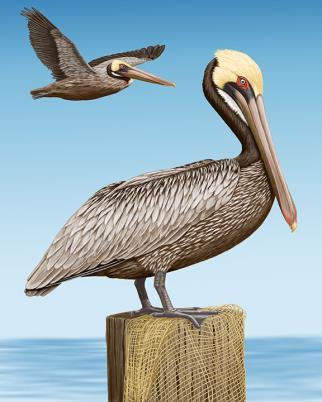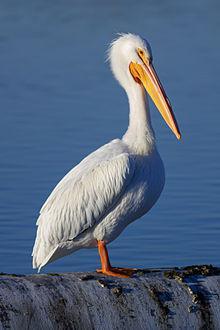The first image is the image on the left, the second image is the image on the right. Analyze the images presented: Is the assertion "One long-beaked bird is floating on water, while a second is flying with wings stretched out showing the black feathery edges." valid? Answer yes or no. No. The first image is the image on the left, the second image is the image on the right. Assess this claim about the two images: "An image shows exactly two pelicans, including one that is in flight.". Correct or not? Answer yes or no. Yes. 